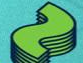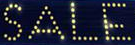What text appears in these images from left to right, separated by a semicolon? ~; SALE 